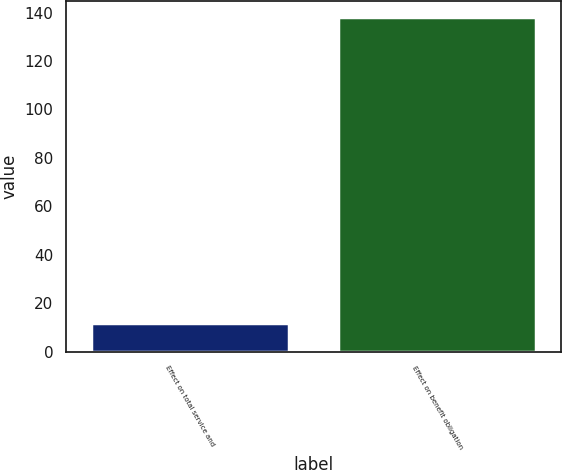Convert chart. <chart><loc_0><loc_0><loc_500><loc_500><bar_chart><fcel>Effect on total service and<fcel>Effect on benefit obligation<nl><fcel>12<fcel>138<nl></chart> 